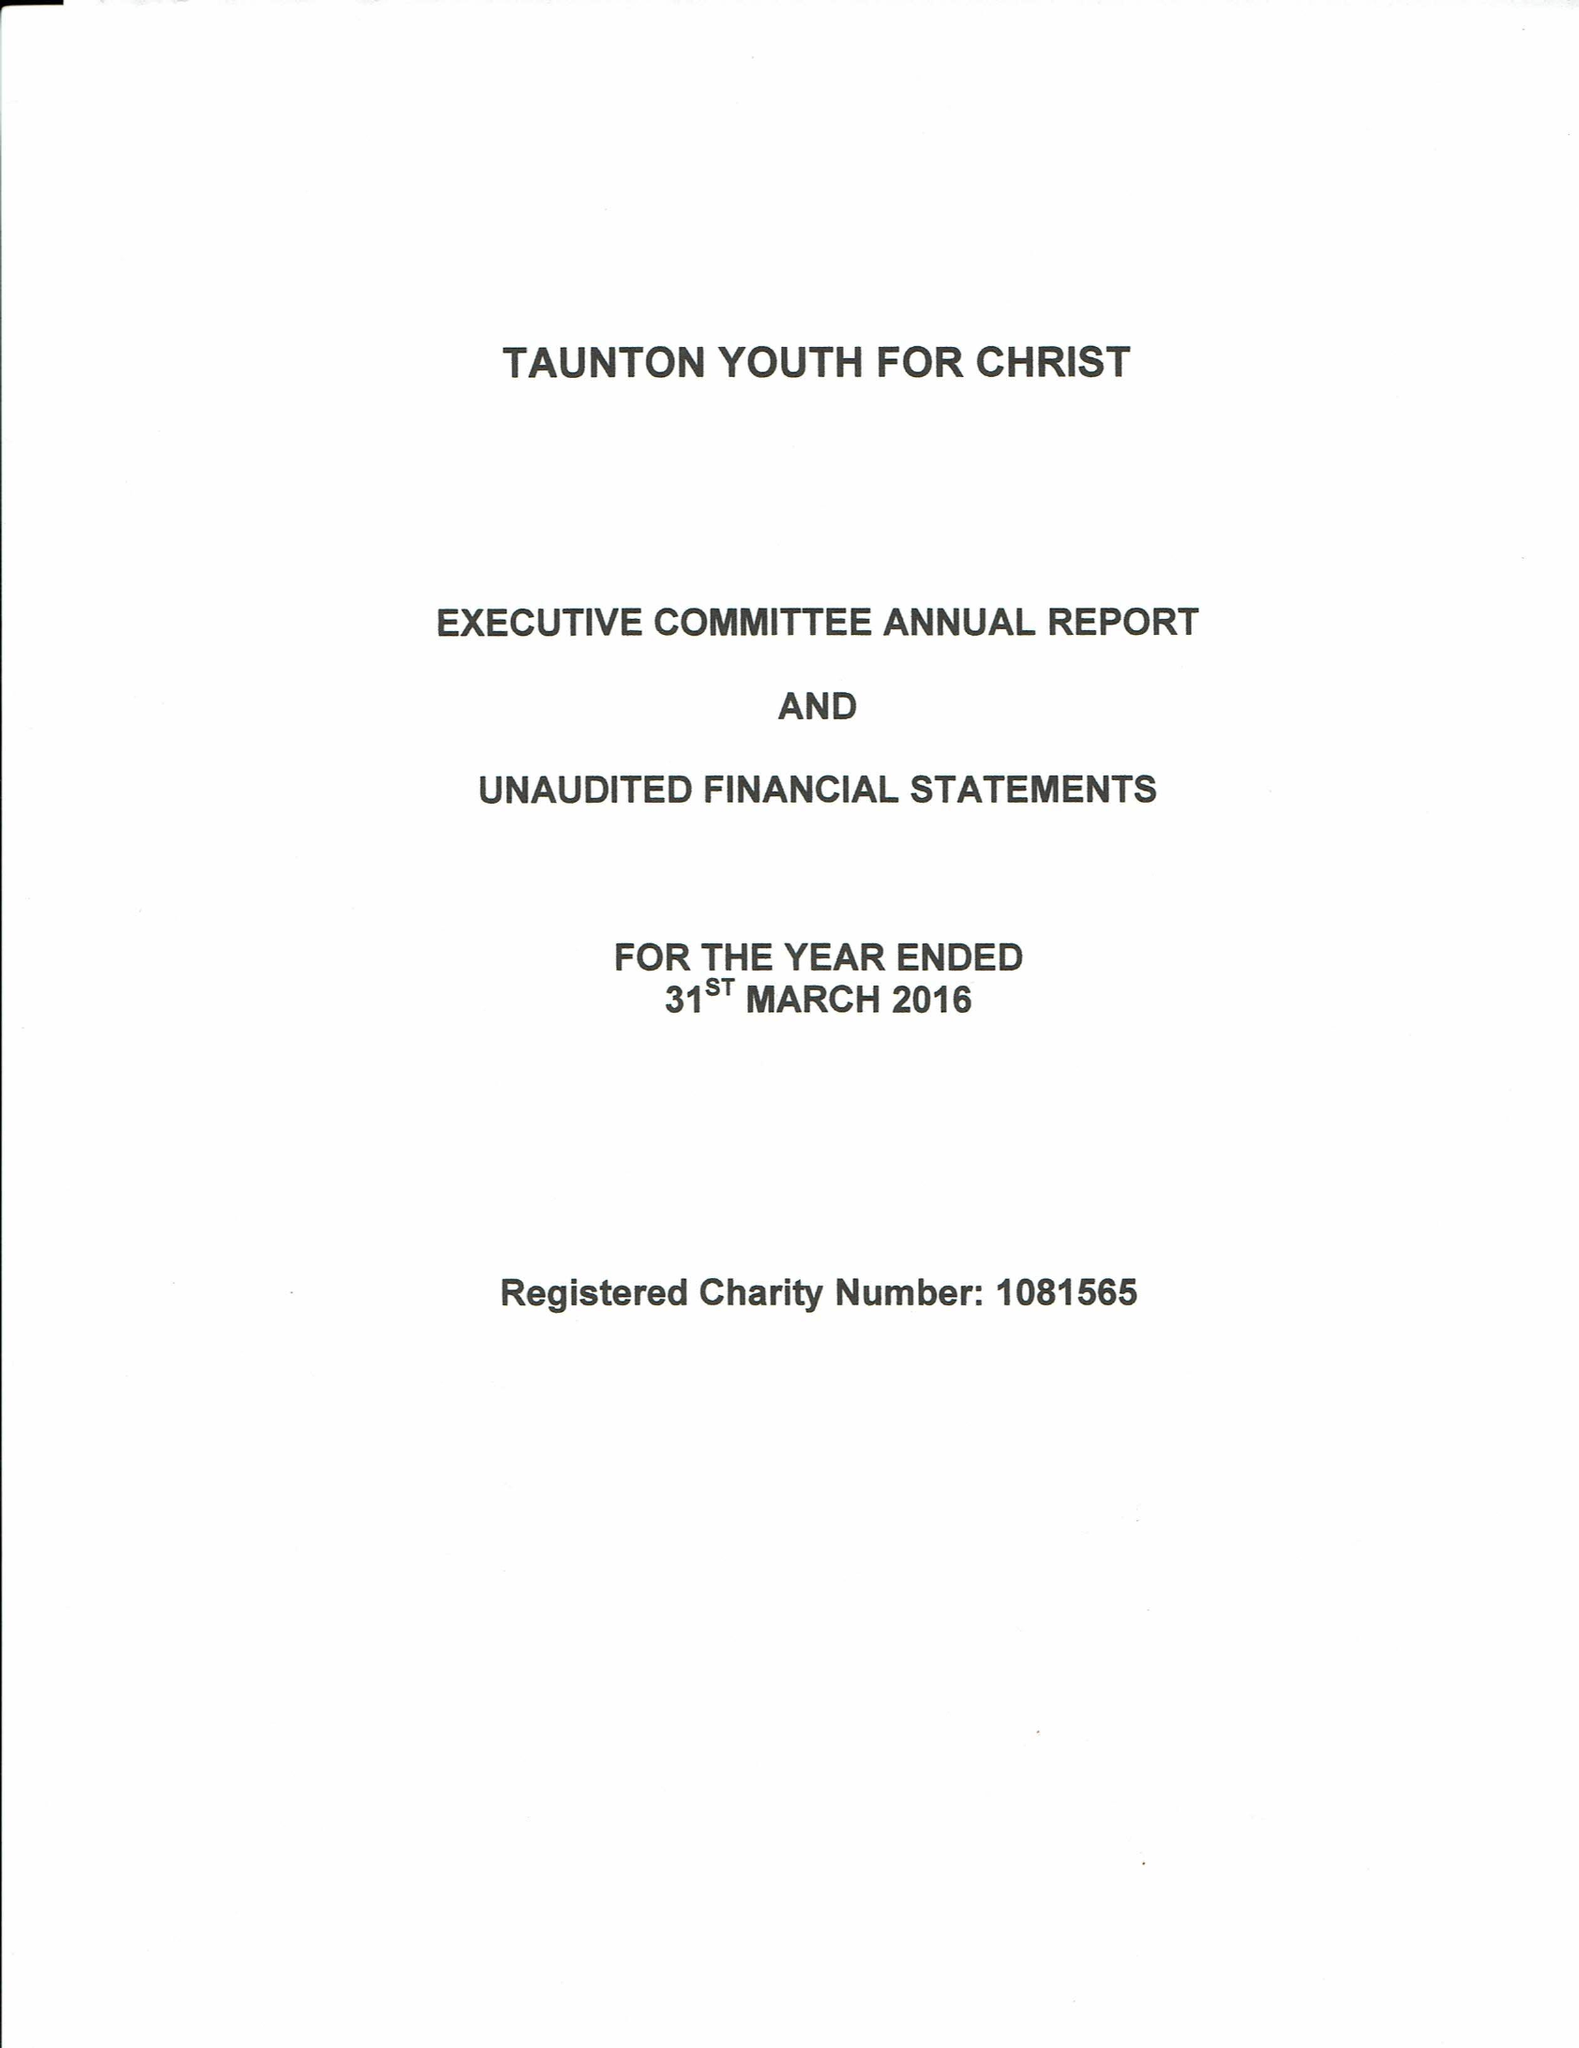What is the value for the address__street_line?
Answer the question using a single word or phrase. 1 FONS GEORGE 